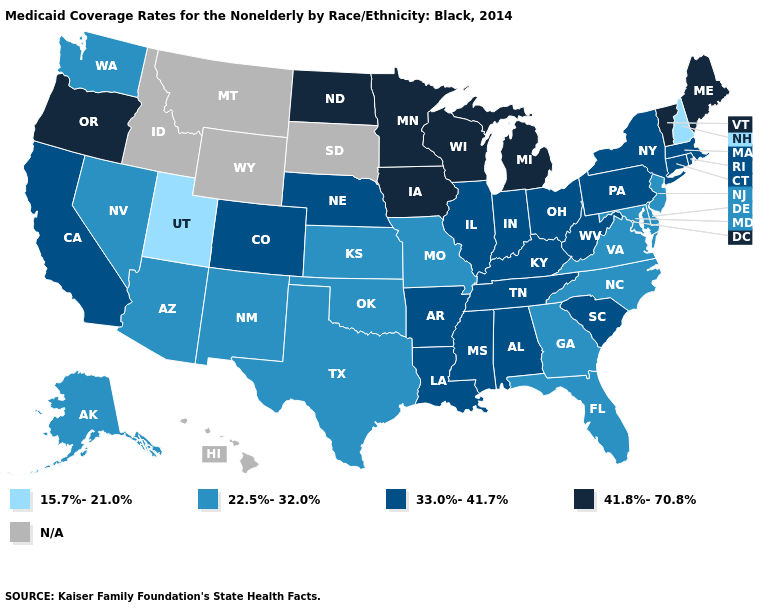What is the value of Mississippi?
Answer briefly. 33.0%-41.7%. What is the highest value in the South ?
Answer briefly. 33.0%-41.7%. Among the states that border Ohio , does West Virginia have the lowest value?
Quick response, please. Yes. Does Nevada have the highest value in the USA?
Short answer required. No. Does South Carolina have the highest value in the South?
Be succinct. Yes. Among the states that border New Hampshire , does Massachusetts have the highest value?
Answer briefly. No. What is the value of North Carolina?
Be succinct. 22.5%-32.0%. Name the states that have a value in the range 15.7%-21.0%?
Give a very brief answer. New Hampshire, Utah. Which states hav the highest value in the MidWest?
Keep it brief. Iowa, Michigan, Minnesota, North Dakota, Wisconsin. What is the value of Idaho?
Quick response, please. N/A. What is the value of Illinois?
Be succinct. 33.0%-41.7%. Name the states that have a value in the range 41.8%-70.8%?
Write a very short answer. Iowa, Maine, Michigan, Minnesota, North Dakota, Oregon, Vermont, Wisconsin. Among the states that border California , does Arizona have the highest value?
Be succinct. No. Among the states that border Oklahoma , which have the lowest value?
Answer briefly. Kansas, Missouri, New Mexico, Texas. What is the value of Arkansas?
Give a very brief answer. 33.0%-41.7%. 